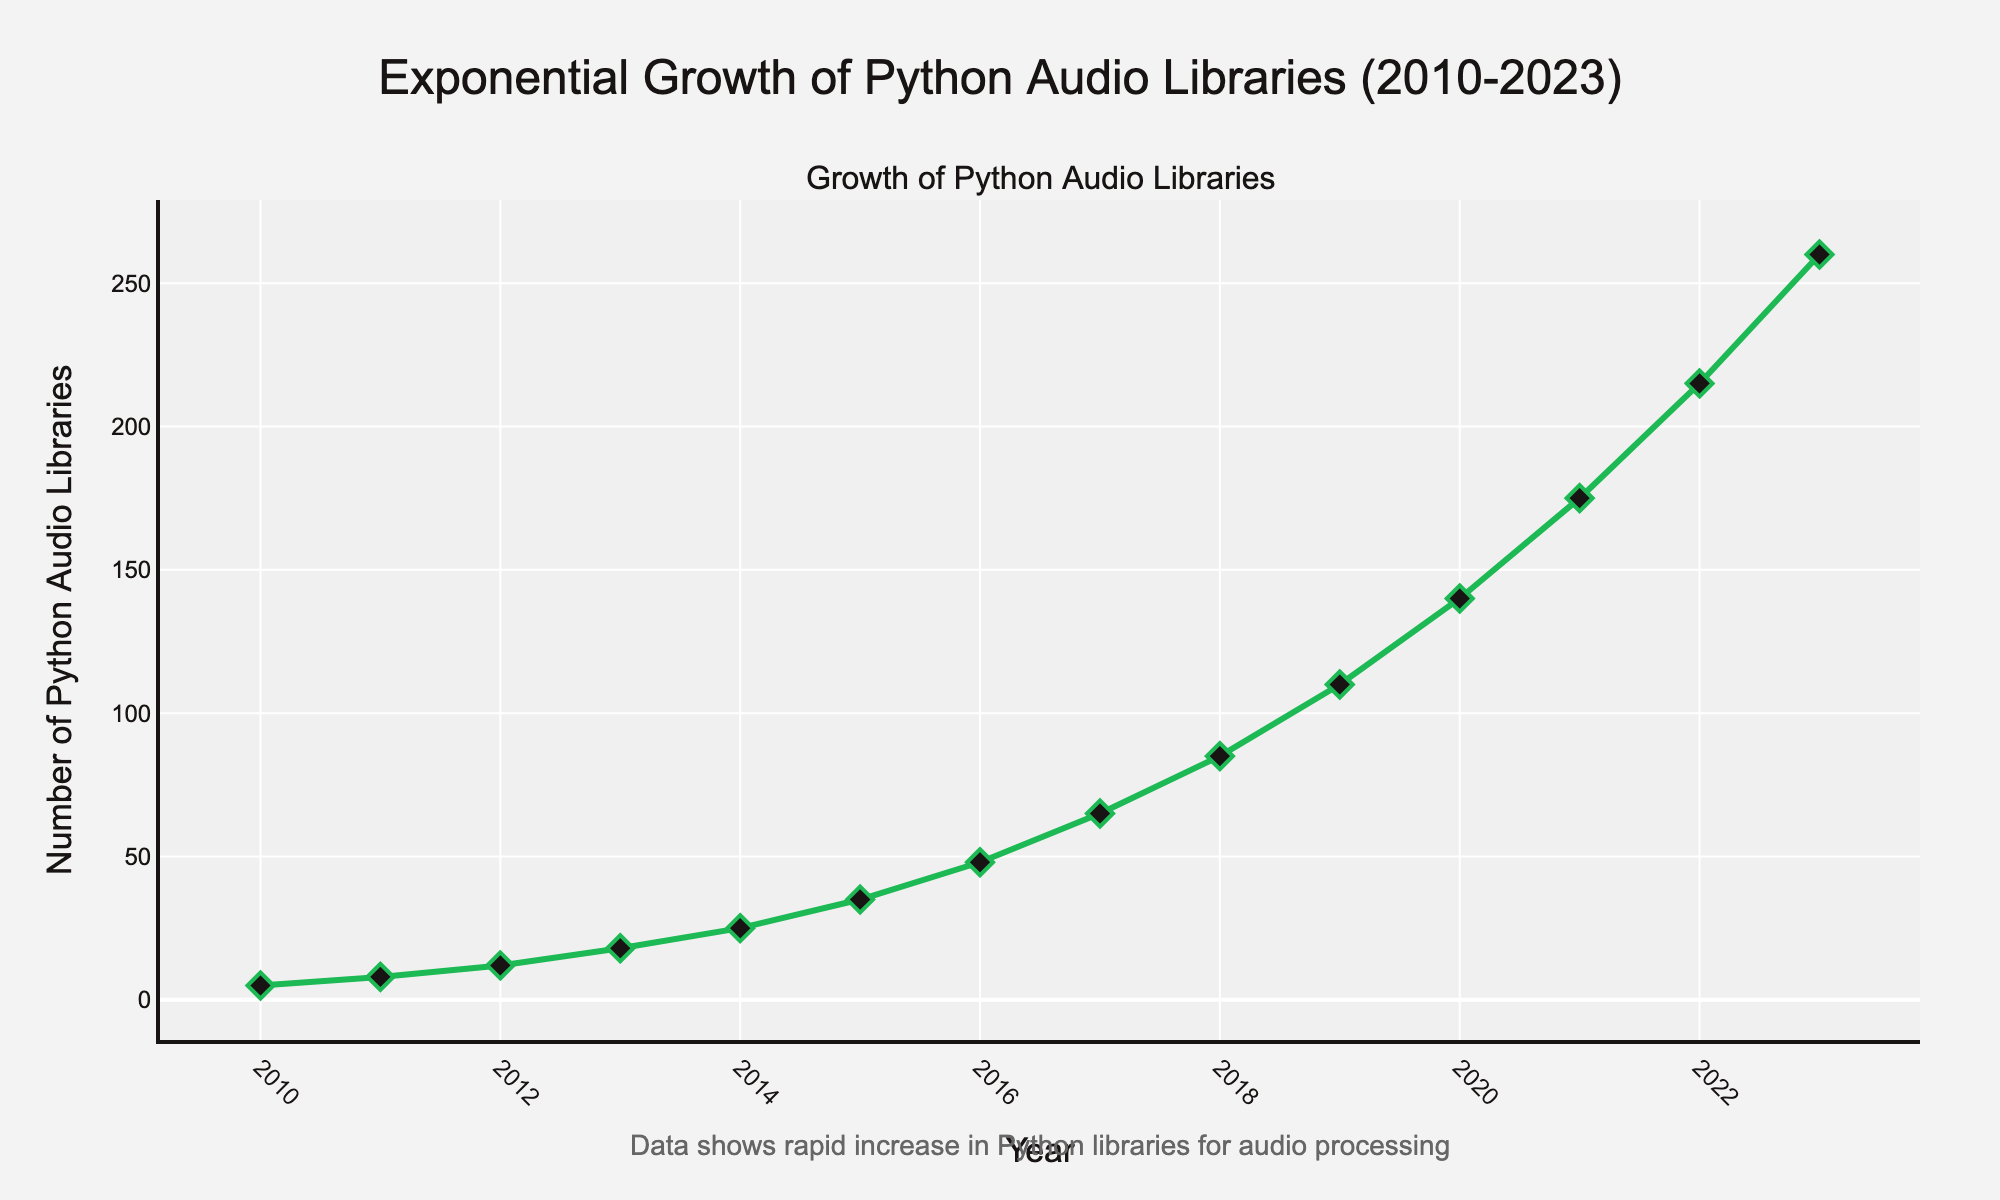What's the growth rate of new Python audio libraries between 2010 and 2023? To calculate the growth rate, first determine the initial and final counts of the libraries. In 2010, there are 5 libraries, and in 2023, there are 260 libraries. The growth rate is (260 - 5) / 5 * 100%.
Answer: 5100% In which year did the number of Python audio libraries first reach or exceed 100? Look at the data points and find the year when the count exceeds or is equal to 100. The count exceeds 100 in 2019 when it reaches 110.
Answer: 2019 How many more libraries were there in 2017 compared to 2015? Subtract the number of libraries in 2015 from the number in 2017: 65 - 35 = 30.
Answer: 30 What is the average annual increase in the number of Python audio libraries between 2010 and 2023? The total increase in the number of libraries between 2010 (5 libraries) and 2023 (260 libraries) is 260 - 5 = 255. The period between 2010 and 2023 is 13 years, so the average annual increase is 255 / 13 ≈ 19.62.
Answer: 19.62 In which year did the number of libraries see the highest absolute increase from the previous year? To find this, calculate the difference year-over-year: 
2011 - 2010 = 3, 
2012 - 2011 = 4, 
2013 - 2012 = 6, 
2014 - 2013 = 7, 
2015 - 2014 = 10, 
2016 - 2015 = 13, 
2017 - 2016 = 17, 
2018 - 2017 = 20, 
2019 - 2018 = 25, 
2020 - 2019 = 30, 
2021 - 2020 = 35, 
2022 - 2021 = 40, 
2023 - 2022 = 45. 
The highest absolute increase is in 2023 with 45 libraries.
Answer: 2023 What can you infer from the overall trend of the graph about the adoption of Python for audio processing? The trend in the graph shows a steady and rapidly increasing number of Python audio libraries from 2010 to 2023. This indicates a significant growth in the adoption and development of Python for audio processing and music production.
Answer: Significant growth 